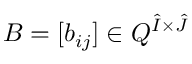<formula> <loc_0><loc_0><loc_500><loc_500>B = [ b _ { i j } ] \in Q ^ { \hat { I } \times \hat { J } }</formula> 